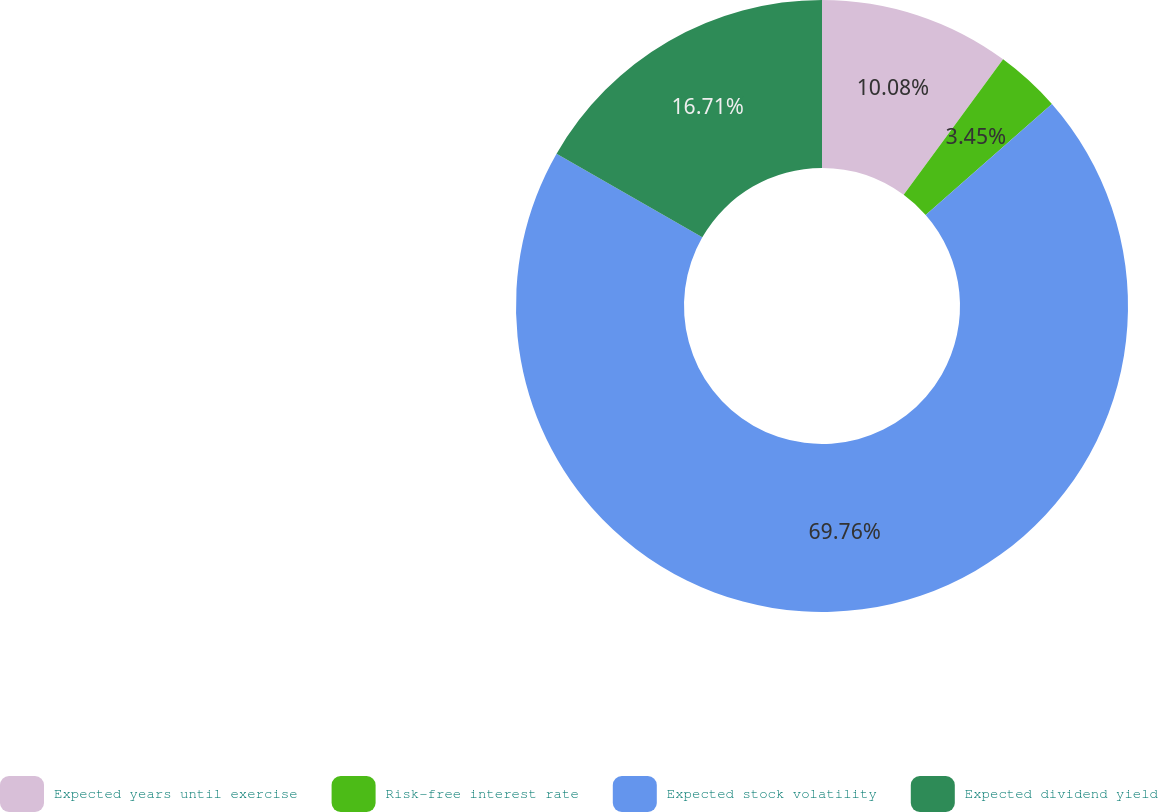<chart> <loc_0><loc_0><loc_500><loc_500><pie_chart><fcel>Expected years until exercise<fcel>Risk-free interest rate<fcel>Expected stock volatility<fcel>Expected dividend yield<nl><fcel>10.08%<fcel>3.45%<fcel>69.75%<fcel>16.71%<nl></chart> 